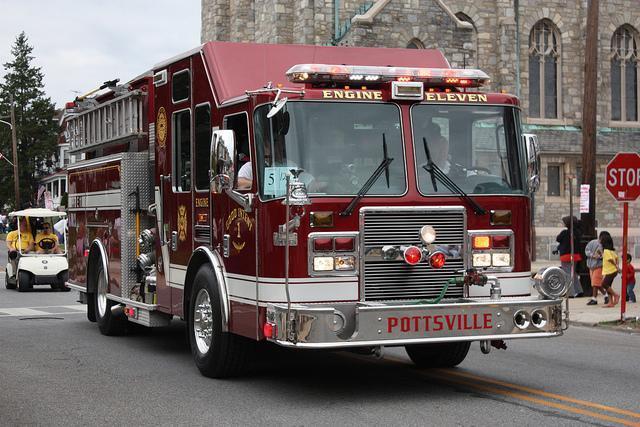Which side of the road is the fire truck driving on?
Indicate the correct response by choosing from the four available options to answer the question.
Options: Middle, left, sidewalk, right. Middle. 